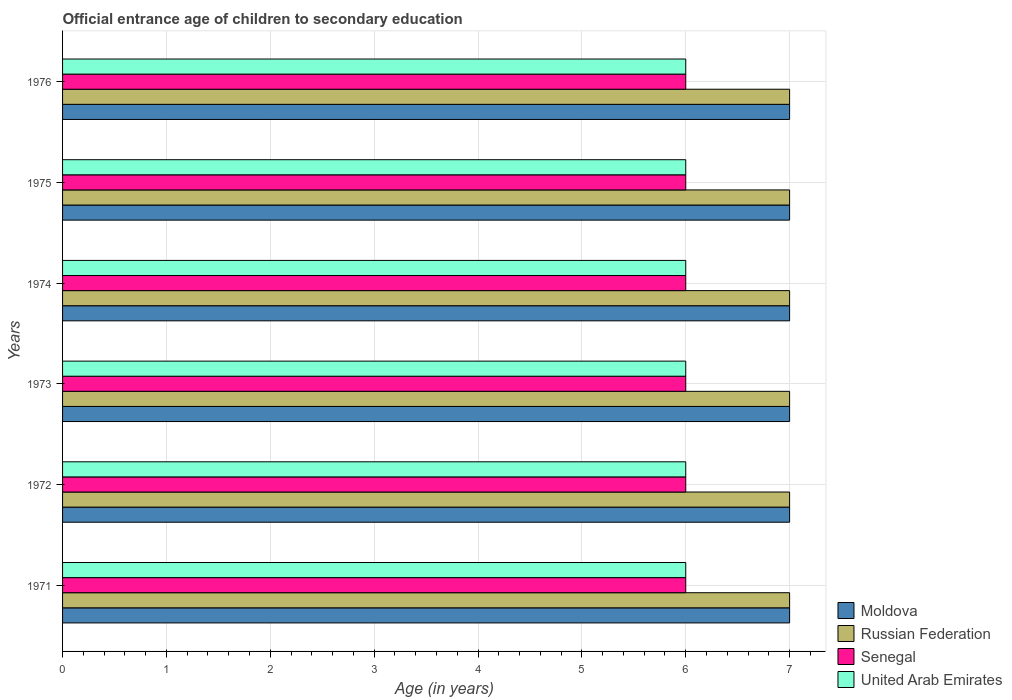How many bars are there on the 6th tick from the top?
Give a very brief answer. 4. What is the label of the 1st group of bars from the top?
Provide a short and direct response. 1976. Across all years, what is the maximum secondary school starting age of children in Russian Federation?
Your response must be concise. 7. Across all years, what is the minimum secondary school starting age of children in Moldova?
Your response must be concise. 7. In which year was the secondary school starting age of children in Senegal maximum?
Your response must be concise. 1971. What is the total secondary school starting age of children in Moldova in the graph?
Offer a terse response. 42. What is the difference between the secondary school starting age of children in United Arab Emirates in 1971 and that in 1974?
Make the answer very short. 0. What is the difference between the secondary school starting age of children in Russian Federation in 1976 and the secondary school starting age of children in Senegal in 1972?
Ensure brevity in your answer.  1. What is the average secondary school starting age of children in Senegal per year?
Your answer should be compact. 6. In the year 1973, what is the difference between the secondary school starting age of children in Moldova and secondary school starting age of children in Senegal?
Provide a short and direct response. 1. What is the ratio of the secondary school starting age of children in Moldova in 1971 to that in 1972?
Your response must be concise. 1. Is the difference between the secondary school starting age of children in Moldova in 1972 and 1974 greater than the difference between the secondary school starting age of children in Senegal in 1972 and 1974?
Make the answer very short. No. What is the difference between the highest and the second highest secondary school starting age of children in United Arab Emirates?
Offer a very short reply. 0. Is the sum of the secondary school starting age of children in Moldova in 1973 and 1974 greater than the maximum secondary school starting age of children in Senegal across all years?
Keep it short and to the point. Yes. Is it the case that in every year, the sum of the secondary school starting age of children in Moldova and secondary school starting age of children in United Arab Emirates is greater than the sum of secondary school starting age of children in Russian Federation and secondary school starting age of children in Senegal?
Offer a terse response. Yes. What does the 1st bar from the top in 1975 represents?
Provide a short and direct response. United Arab Emirates. What does the 3rd bar from the bottom in 1974 represents?
Your answer should be very brief. Senegal. Is it the case that in every year, the sum of the secondary school starting age of children in United Arab Emirates and secondary school starting age of children in Russian Federation is greater than the secondary school starting age of children in Senegal?
Provide a short and direct response. Yes. Are all the bars in the graph horizontal?
Keep it short and to the point. Yes. How many years are there in the graph?
Make the answer very short. 6. What is the difference between two consecutive major ticks on the X-axis?
Your answer should be compact. 1. Are the values on the major ticks of X-axis written in scientific E-notation?
Your response must be concise. No. Does the graph contain any zero values?
Your answer should be very brief. No. How many legend labels are there?
Offer a terse response. 4. How are the legend labels stacked?
Offer a terse response. Vertical. What is the title of the graph?
Offer a very short reply. Official entrance age of children to secondary education. Does "Middle income" appear as one of the legend labels in the graph?
Make the answer very short. No. What is the label or title of the X-axis?
Make the answer very short. Age (in years). What is the label or title of the Y-axis?
Make the answer very short. Years. What is the Age (in years) of Russian Federation in 1971?
Keep it short and to the point. 7. What is the Age (in years) of United Arab Emirates in 1971?
Make the answer very short. 6. What is the Age (in years) in Moldova in 1972?
Give a very brief answer. 7. What is the Age (in years) of Russian Federation in 1972?
Offer a terse response. 7. What is the Age (in years) in Senegal in 1972?
Provide a succinct answer. 6. What is the Age (in years) of Russian Federation in 1974?
Provide a short and direct response. 7. What is the Age (in years) of Moldova in 1975?
Your answer should be compact. 7. What is the Age (in years) of Senegal in 1975?
Provide a short and direct response. 6. What is the Age (in years) in United Arab Emirates in 1975?
Your response must be concise. 6. What is the Age (in years) of Moldova in 1976?
Ensure brevity in your answer.  7. Across all years, what is the maximum Age (in years) of Russian Federation?
Ensure brevity in your answer.  7. Across all years, what is the maximum Age (in years) of United Arab Emirates?
Give a very brief answer. 6. Across all years, what is the minimum Age (in years) in Senegal?
Your answer should be very brief. 6. What is the total Age (in years) in Moldova in the graph?
Provide a short and direct response. 42. What is the total Age (in years) in Russian Federation in the graph?
Your answer should be compact. 42. What is the difference between the Age (in years) of Moldova in 1971 and that in 1972?
Ensure brevity in your answer.  0. What is the difference between the Age (in years) of Senegal in 1971 and that in 1972?
Keep it short and to the point. 0. What is the difference between the Age (in years) of United Arab Emirates in 1971 and that in 1972?
Your response must be concise. 0. What is the difference between the Age (in years) of Russian Federation in 1971 and that in 1973?
Your answer should be compact. 0. What is the difference between the Age (in years) of Russian Federation in 1971 and that in 1974?
Ensure brevity in your answer.  0. What is the difference between the Age (in years) of United Arab Emirates in 1971 and that in 1974?
Offer a terse response. 0. What is the difference between the Age (in years) in Russian Federation in 1971 and that in 1975?
Keep it short and to the point. 0. What is the difference between the Age (in years) of United Arab Emirates in 1971 and that in 1975?
Make the answer very short. 0. What is the difference between the Age (in years) in Moldova in 1971 and that in 1976?
Keep it short and to the point. 0. What is the difference between the Age (in years) of Moldova in 1972 and that in 1973?
Give a very brief answer. 0. What is the difference between the Age (in years) of Russian Federation in 1972 and that in 1973?
Offer a terse response. 0. What is the difference between the Age (in years) in United Arab Emirates in 1972 and that in 1973?
Offer a very short reply. 0. What is the difference between the Age (in years) in Moldova in 1972 and that in 1974?
Offer a terse response. 0. What is the difference between the Age (in years) of Senegal in 1972 and that in 1974?
Provide a succinct answer. 0. What is the difference between the Age (in years) of United Arab Emirates in 1972 and that in 1974?
Provide a short and direct response. 0. What is the difference between the Age (in years) in Moldova in 1972 and that in 1975?
Your answer should be very brief. 0. What is the difference between the Age (in years) of United Arab Emirates in 1972 and that in 1975?
Provide a succinct answer. 0. What is the difference between the Age (in years) of Moldova in 1972 and that in 1976?
Your answer should be very brief. 0. What is the difference between the Age (in years) of United Arab Emirates in 1972 and that in 1976?
Make the answer very short. 0. What is the difference between the Age (in years) in Russian Federation in 1973 and that in 1974?
Give a very brief answer. 0. What is the difference between the Age (in years) of Senegal in 1973 and that in 1974?
Your answer should be very brief. 0. What is the difference between the Age (in years) of United Arab Emirates in 1973 and that in 1974?
Give a very brief answer. 0. What is the difference between the Age (in years) of Moldova in 1973 and that in 1975?
Provide a succinct answer. 0. What is the difference between the Age (in years) in Russian Federation in 1973 and that in 1975?
Provide a succinct answer. 0. What is the difference between the Age (in years) in Senegal in 1973 and that in 1975?
Ensure brevity in your answer.  0. What is the difference between the Age (in years) of United Arab Emirates in 1973 and that in 1975?
Offer a terse response. 0. What is the difference between the Age (in years) in Russian Federation in 1973 and that in 1976?
Provide a short and direct response. 0. What is the difference between the Age (in years) in Moldova in 1974 and that in 1975?
Give a very brief answer. 0. What is the difference between the Age (in years) in Senegal in 1974 and that in 1975?
Your answer should be compact. 0. What is the difference between the Age (in years) in Moldova in 1974 and that in 1976?
Offer a very short reply. 0. What is the difference between the Age (in years) in Russian Federation in 1974 and that in 1976?
Your answer should be compact. 0. What is the difference between the Age (in years) of Senegal in 1974 and that in 1976?
Give a very brief answer. 0. What is the difference between the Age (in years) of United Arab Emirates in 1974 and that in 1976?
Keep it short and to the point. 0. What is the difference between the Age (in years) in Russian Federation in 1975 and that in 1976?
Offer a very short reply. 0. What is the difference between the Age (in years) of Senegal in 1975 and that in 1976?
Make the answer very short. 0. What is the difference between the Age (in years) of United Arab Emirates in 1975 and that in 1976?
Provide a short and direct response. 0. What is the difference between the Age (in years) of Moldova in 1971 and the Age (in years) of Russian Federation in 1972?
Give a very brief answer. 0. What is the difference between the Age (in years) of Moldova in 1971 and the Age (in years) of Senegal in 1972?
Your response must be concise. 1. What is the difference between the Age (in years) in Moldova in 1971 and the Age (in years) in United Arab Emirates in 1972?
Keep it short and to the point. 1. What is the difference between the Age (in years) in Russian Federation in 1971 and the Age (in years) in Senegal in 1972?
Provide a short and direct response. 1. What is the difference between the Age (in years) in Senegal in 1971 and the Age (in years) in United Arab Emirates in 1972?
Offer a terse response. 0. What is the difference between the Age (in years) of Moldova in 1971 and the Age (in years) of United Arab Emirates in 1973?
Give a very brief answer. 1. What is the difference between the Age (in years) of Russian Federation in 1971 and the Age (in years) of Senegal in 1973?
Your answer should be very brief. 1. What is the difference between the Age (in years) in Russian Federation in 1971 and the Age (in years) in United Arab Emirates in 1973?
Your answer should be very brief. 1. What is the difference between the Age (in years) of Senegal in 1971 and the Age (in years) of United Arab Emirates in 1973?
Make the answer very short. 0. What is the difference between the Age (in years) in Moldova in 1971 and the Age (in years) in Russian Federation in 1974?
Ensure brevity in your answer.  0. What is the difference between the Age (in years) in Russian Federation in 1971 and the Age (in years) in Senegal in 1974?
Keep it short and to the point. 1. What is the difference between the Age (in years) in Senegal in 1971 and the Age (in years) in United Arab Emirates in 1974?
Your answer should be compact. 0. What is the difference between the Age (in years) of Moldova in 1971 and the Age (in years) of Russian Federation in 1975?
Make the answer very short. 0. What is the difference between the Age (in years) of Moldova in 1971 and the Age (in years) of Senegal in 1975?
Provide a short and direct response. 1. What is the difference between the Age (in years) in Russian Federation in 1971 and the Age (in years) in Senegal in 1975?
Provide a succinct answer. 1. What is the difference between the Age (in years) in Senegal in 1971 and the Age (in years) in United Arab Emirates in 1975?
Ensure brevity in your answer.  0. What is the difference between the Age (in years) of Moldova in 1971 and the Age (in years) of Russian Federation in 1976?
Keep it short and to the point. 0. What is the difference between the Age (in years) in Moldova in 1971 and the Age (in years) in Senegal in 1976?
Ensure brevity in your answer.  1. What is the difference between the Age (in years) of Russian Federation in 1971 and the Age (in years) of Senegal in 1976?
Your answer should be very brief. 1. What is the difference between the Age (in years) of Russian Federation in 1971 and the Age (in years) of United Arab Emirates in 1976?
Provide a succinct answer. 1. What is the difference between the Age (in years) of Senegal in 1971 and the Age (in years) of United Arab Emirates in 1976?
Provide a short and direct response. 0. What is the difference between the Age (in years) in Moldova in 1972 and the Age (in years) in Senegal in 1973?
Keep it short and to the point. 1. What is the difference between the Age (in years) in Moldova in 1972 and the Age (in years) in United Arab Emirates in 1973?
Provide a succinct answer. 1. What is the difference between the Age (in years) of Russian Federation in 1972 and the Age (in years) of Senegal in 1973?
Make the answer very short. 1. What is the difference between the Age (in years) of Russian Federation in 1972 and the Age (in years) of United Arab Emirates in 1973?
Your response must be concise. 1. What is the difference between the Age (in years) of Senegal in 1972 and the Age (in years) of United Arab Emirates in 1973?
Provide a succinct answer. 0. What is the difference between the Age (in years) of Moldova in 1972 and the Age (in years) of Senegal in 1974?
Offer a terse response. 1. What is the difference between the Age (in years) of Moldova in 1972 and the Age (in years) of United Arab Emirates in 1974?
Give a very brief answer. 1. What is the difference between the Age (in years) in Moldova in 1972 and the Age (in years) in Russian Federation in 1975?
Provide a short and direct response. 0. What is the difference between the Age (in years) in Moldova in 1972 and the Age (in years) in Senegal in 1975?
Make the answer very short. 1. What is the difference between the Age (in years) in Senegal in 1972 and the Age (in years) in United Arab Emirates in 1975?
Your answer should be compact. 0. What is the difference between the Age (in years) of Moldova in 1972 and the Age (in years) of Russian Federation in 1976?
Ensure brevity in your answer.  0. What is the difference between the Age (in years) of Senegal in 1972 and the Age (in years) of United Arab Emirates in 1976?
Provide a short and direct response. 0. What is the difference between the Age (in years) of Moldova in 1973 and the Age (in years) of Russian Federation in 1974?
Provide a short and direct response. 0. What is the difference between the Age (in years) in Moldova in 1973 and the Age (in years) in Senegal in 1974?
Your answer should be very brief. 1. What is the difference between the Age (in years) in Russian Federation in 1973 and the Age (in years) in Senegal in 1974?
Provide a succinct answer. 1. What is the difference between the Age (in years) in Russian Federation in 1973 and the Age (in years) in United Arab Emirates in 1974?
Give a very brief answer. 1. What is the difference between the Age (in years) in Russian Federation in 1973 and the Age (in years) in Senegal in 1975?
Your answer should be compact. 1. What is the difference between the Age (in years) of Russian Federation in 1973 and the Age (in years) of United Arab Emirates in 1975?
Your answer should be very brief. 1. What is the difference between the Age (in years) in Moldova in 1973 and the Age (in years) in Senegal in 1976?
Your answer should be very brief. 1. What is the difference between the Age (in years) in Russian Federation in 1973 and the Age (in years) in Senegal in 1976?
Provide a succinct answer. 1. What is the difference between the Age (in years) of Moldova in 1974 and the Age (in years) of Russian Federation in 1975?
Give a very brief answer. 0. What is the difference between the Age (in years) of Moldova in 1974 and the Age (in years) of Senegal in 1975?
Offer a terse response. 1. What is the difference between the Age (in years) of Moldova in 1974 and the Age (in years) of United Arab Emirates in 1975?
Your answer should be compact. 1. What is the difference between the Age (in years) in Senegal in 1974 and the Age (in years) in United Arab Emirates in 1975?
Provide a succinct answer. 0. What is the difference between the Age (in years) of Moldova in 1974 and the Age (in years) of Senegal in 1976?
Keep it short and to the point. 1. What is the difference between the Age (in years) of Moldova in 1974 and the Age (in years) of United Arab Emirates in 1976?
Keep it short and to the point. 1. What is the difference between the Age (in years) in Russian Federation in 1974 and the Age (in years) in Senegal in 1976?
Offer a very short reply. 1. What is the difference between the Age (in years) in Russian Federation in 1974 and the Age (in years) in United Arab Emirates in 1976?
Provide a short and direct response. 1. What is the difference between the Age (in years) of Senegal in 1974 and the Age (in years) of United Arab Emirates in 1976?
Provide a succinct answer. 0. What is the difference between the Age (in years) of Moldova in 1975 and the Age (in years) of Russian Federation in 1976?
Keep it short and to the point. 0. What is the difference between the Age (in years) in Russian Federation in 1975 and the Age (in years) in United Arab Emirates in 1976?
Your response must be concise. 1. What is the difference between the Age (in years) of Senegal in 1975 and the Age (in years) of United Arab Emirates in 1976?
Give a very brief answer. 0. What is the average Age (in years) in United Arab Emirates per year?
Offer a very short reply. 6. In the year 1971, what is the difference between the Age (in years) of Moldova and Age (in years) of Russian Federation?
Provide a short and direct response. 0. In the year 1971, what is the difference between the Age (in years) in Moldova and Age (in years) in Senegal?
Keep it short and to the point. 1. In the year 1971, what is the difference between the Age (in years) of Moldova and Age (in years) of United Arab Emirates?
Make the answer very short. 1. In the year 1971, what is the difference between the Age (in years) of Russian Federation and Age (in years) of Senegal?
Provide a succinct answer. 1. In the year 1971, what is the difference between the Age (in years) of Russian Federation and Age (in years) of United Arab Emirates?
Ensure brevity in your answer.  1. In the year 1971, what is the difference between the Age (in years) of Senegal and Age (in years) of United Arab Emirates?
Provide a short and direct response. 0. In the year 1972, what is the difference between the Age (in years) in Moldova and Age (in years) in Senegal?
Ensure brevity in your answer.  1. In the year 1972, what is the difference between the Age (in years) of Russian Federation and Age (in years) of United Arab Emirates?
Keep it short and to the point. 1. In the year 1973, what is the difference between the Age (in years) in Moldova and Age (in years) in United Arab Emirates?
Give a very brief answer. 1. In the year 1973, what is the difference between the Age (in years) in Russian Federation and Age (in years) in Senegal?
Ensure brevity in your answer.  1. In the year 1973, what is the difference between the Age (in years) in Russian Federation and Age (in years) in United Arab Emirates?
Your response must be concise. 1. In the year 1973, what is the difference between the Age (in years) of Senegal and Age (in years) of United Arab Emirates?
Give a very brief answer. 0. In the year 1974, what is the difference between the Age (in years) in Moldova and Age (in years) in Senegal?
Make the answer very short. 1. In the year 1974, what is the difference between the Age (in years) of Russian Federation and Age (in years) of Senegal?
Keep it short and to the point. 1. In the year 1974, what is the difference between the Age (in years) in Russian Federation and Age (in years) in United Arab Emirates?
Your answer should be very brief. 1. In the year 1974, what is the difference between the Age (in years) of Senegal and Age (in years) of United Arab Emirates?
Offer a very short reply. 0. In the year 1975, what is the difference between the Age (in years) in Moldova and Age (in years) in Russian Federation?
Keep it short and to the point. 0. In the year 1975, what is the difference between the Age (in years) of Moldova and Age (in years) of United Arab Emirates?
Offer a very short reply. 1. In the year 1976, what is the difference between the Age (in years) in Moldova and Age (in years) in Russian Federation?
Your response must be concise. 0. In the year 1976, what is the difference between the Age (in years) of Moldova and Age (in years) of Senegal?
Ensure brevity in your answer.  1. In the year 1976, what is the difference between the Age (in years) in Moldova and Age (in years) in United Arab Emirates?
Ensure brevity in your answer.  1. In the year 1976, what is the difference between the Age (in years) in Russian Federation and Age (in years) in United Arab Emirates?
Offer a very short reply. 1. What is the ratio of the Age (in years) in Moldova in 1971 to that in 1972?
Give a very brief answer. 1. What is the ratio of the Age (in years) in Russian Federation in 1971 to that in 1973?
Give a very brief answer. 1. What is the ratio of the Age (in years) of Senegal in 1971 to that in 1973?
Provide a succinct answer. 1. What is the ratio of the Age (in years) in United Arab Emirates in 1971 to that in 1973?
Your answer should be compact. 1. What is the ratio of the Age (in years) of Moldova in 1971 to that in 1974?
Give a very brief answer. 1. What is the ratio of the Age (in years) in Russian Federation in 1971 to that in 1974?
Provide a succinct answer. 1. What is the ratio of the Age (in years) of Senegal in 1971 to that in 1974?
Ensure brevity in your answer.  1. What is the ratio of the Age (in years) in Moldova in 1971 to that in 1975?
Provide a short and direct response. 1. What is the ratio of the Age (in years) in Russian Federation in 1971 to that in 1975?
Give a very brief answer. 1. What is the ratio of the Age (in years) of Senegal in 1972 to that in 1973?
Keep it short and to the point. 1. What is the ratio of the Age (in years) in United Arab Emirates in 1972 to that in 1973?
Provide a succinct answer. 1. What is the ratio of the Age (in years) in Moldova in 1972 to that in 1974?
Offer a terse response. 1. What is the ratio of the Age (in years) of Russian Federation in 1972 to that in 1974?
Give a very brief answer. 1. What is the ratio of the Age (in years) of Senegal in 1972 to that in 1974?
Ensure brevity in your answer.  1. What is the ratio of the Age (in years) of Moldova in 1972 to that in 1975?
Your response must be concise. 1. What is the ratio of the Age (in years) of Russian Federation in 1972 to that in 1975?
Your response must be concise. 1. What is the ratio of the Age (in years) of Senegal in 1972 to that in 1975?
Offer a very short reply. 1. What is the ratio of the Age (in years) in Russian Federation in 1973 to that in 1974?
Provide a succinct answer. 1. What is the ratio of the Age (in years) in Senegal in 1973 to that in 1974?
Offer a very short reply. 1. What is the ratio of the Age (in years) of United Arab Emirates in 1973 to that in 1974?
Your answer should be very brief. 1. What is the ratio of the Age (in years) in Moldova in 1973 to that in 1975?
Offer a very short reply. 1. What is the ratio of the Age (in years) of Russian Federation in 1973 to that in 1975?
Keep it short and to the point. 1. What is the ratio of the Age (in years) in Senegal in 1973 to that in 1976?
Provide a short and direct response. 1. What is the ratio of the Age (in years) in Moldova in 1974 to that in 1975?
Keep it short and to the point. 1. What is the ratio of the Age (in years) of Russian Federation in 1974 to that in 1975?
Your answer should be very brief. 1. What is the ratio of the Age (in years) of Senegal in 1974 to that in 1975?
Ensure brevity in your answer.  1. What is the ratio of the Age (in years) in Russian Federation in 1974 to that in 1976?
Your answer should be compact. 1. What is the ratio of the Age (in years) of United Arab Emirates in 1974 to that in 1976?
Your answer should be compact. 1. What is the difference between the highest and the second highest Age (in years) in Russian Federation?
Offer a very short reply. 0. What is the difference between the highest and the second highest Age (in years) in United Arab Emirates?
Give a very brief answer. 0. What is the difference between the highest and the lowest Age (in years) in Senegal?
Provide a short and direct response. 0. What is the difference between the highest and the lowest Age (in years) in United Arab Emirates?
Ensure brevity in your answer.  0. 